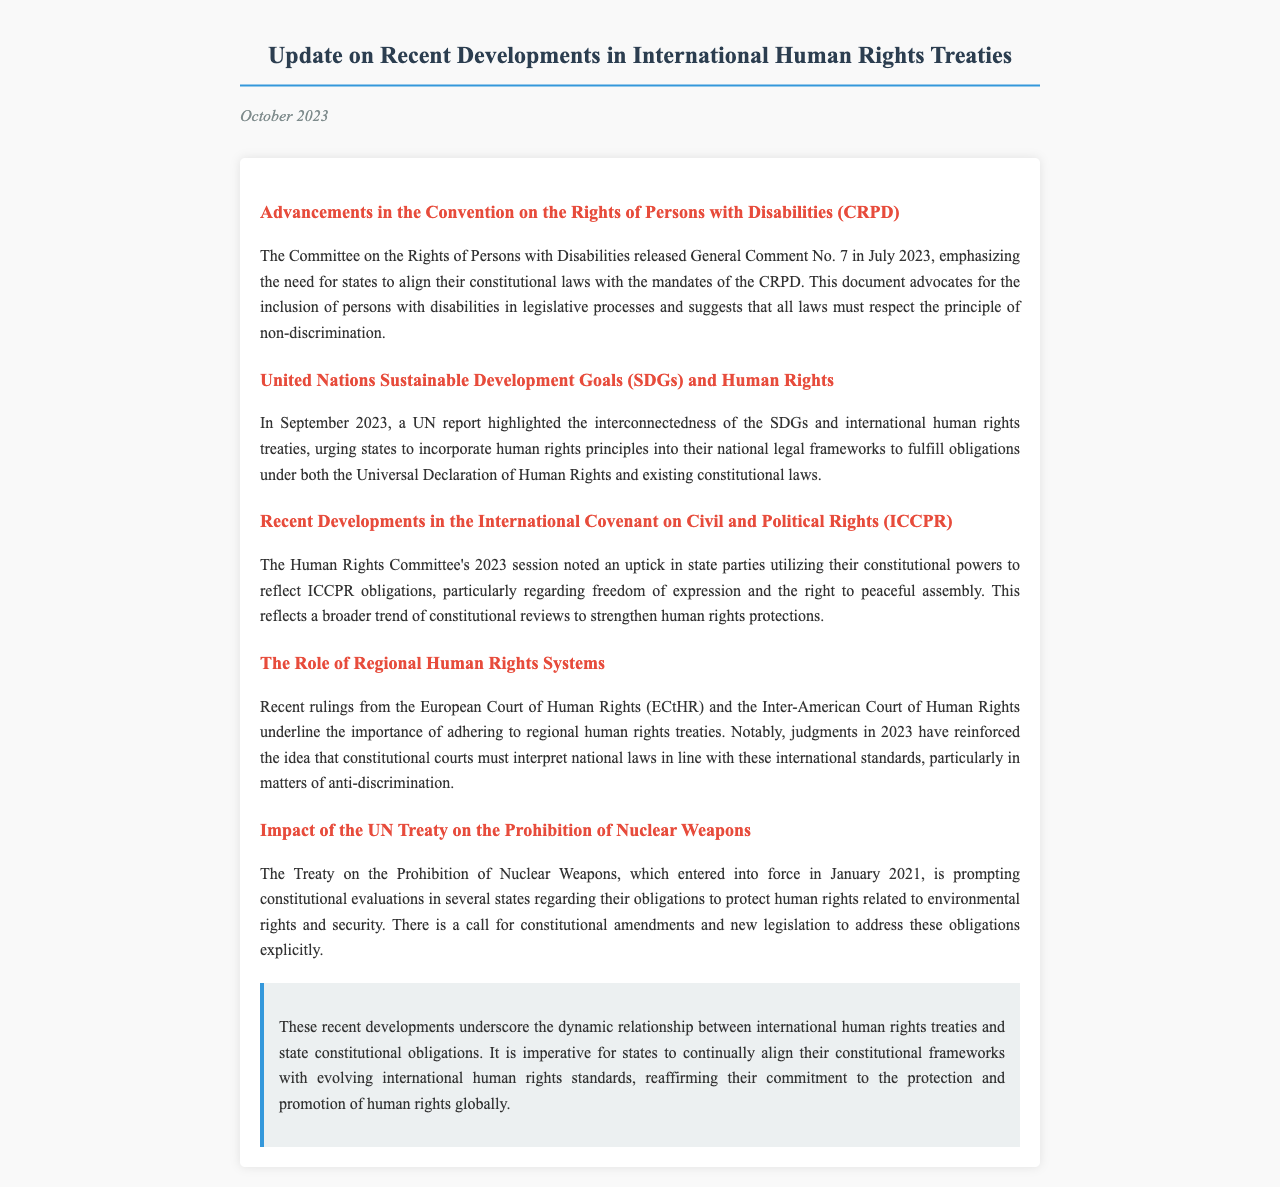What is the title of the document? The title can be found in the header of the document.
Answer: Update on Recent Developments in International Human Rights Treaties In which month was General Comment No. 7 released? The month of release is mentioned in the section about the CRPD advancements.
Answer: July What are the two key themes discussed in the UN report from September 2023? Key themes from the UN report are highlighted within the relevant section of the document.
Answer: SDGs and human rights What is the main focus of the ICCPR session noted in 2023? The focus is described in the section covering developments in the ICCPR.
Answer: Freedom of expression and the right to peaceful assembly When did the Treaty on the Prohibition of Nuclear Weapons enter into force? The date of entry into force is specified within the section discussing the treaty.
Answer: January 2021 Which regional court's recent rulings emphasize adherence to human rights treaties? The relevant court is referenced in the section discussing regional human rights systems.
Answer: European Court of Human Rights What does the Committee on the Rights of Persons with Disabilities advocate for? The advocacy points are outlined in the section about the CRPD advancements.
Answer: Inclusion of persons with disabilities in legislative processes What is the conclusion about the relationship between treaties and constitutional obligations? The conclusion summarizes the insights gained from recent developments discussed in the letter.
Answer: Dynamic relationship 